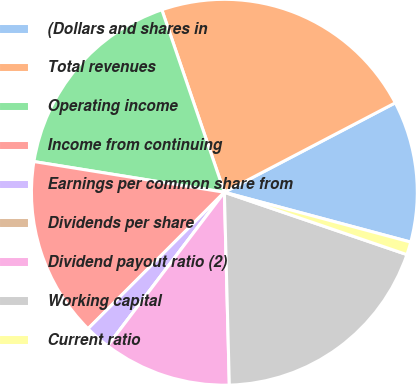<chart> <loc_0><loc_0><loc_500><loc_500><pie_chart><fcel>(Dollars and shares in<fcel>Total revenues<fcel>Operating income<fcel>Income from continuing<fcel>Earnings per common share from<fcel>Dividends per share<fcel>Dividend payout ratio (2)<fcel>Working capital<fcel>Current ratio<nl><fcel>11.83%<fcel>22.58%<fcel>17.2%<fcel>15.05%<fcel>2.15%<fcel>0.0%<fcel>10.75%<fcel>19.35%<fcel>1.08%<nl></chart> 